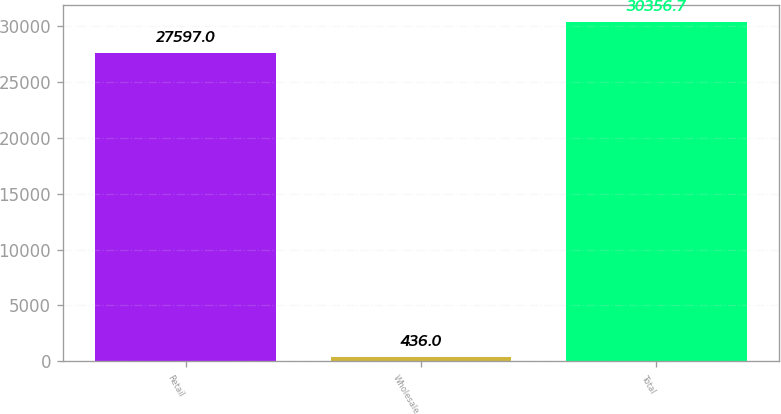Convert chart. <chart><loc_0><loc_0><loc_500><loc_500><bar_chart><fcel>Retail<fcel>Wholesale<fcel>Total<nl><fcel>27597<fcel>436<fcel>30356.7<nl></chart> 